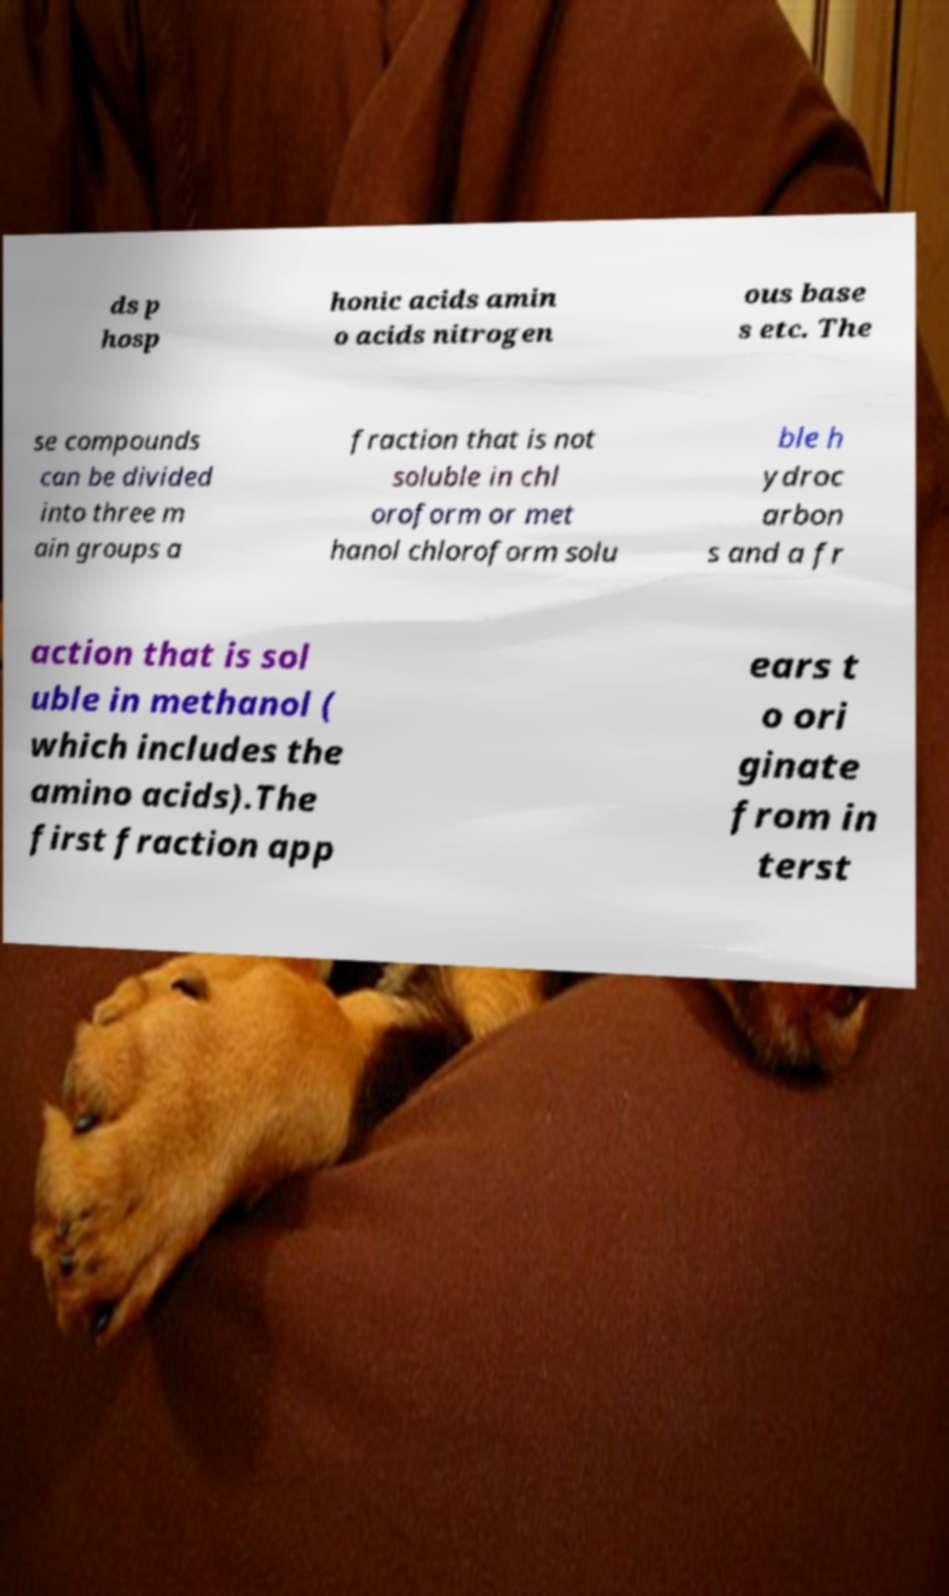For documentation purposes, I need the text within this image transcribed. Could you provide that? ds p hosp honic acids amin o acids nitrogen ous base s etc. The se compounds can be divided into three m ain groups a fraction that is not soluble in chl oroform or met hanol chloroform solu ble h ydroc arbon s and a fr action that is sol uble in methanol ( which includes the amino acids).The first fraction app ears t o ori ginate from in terst 